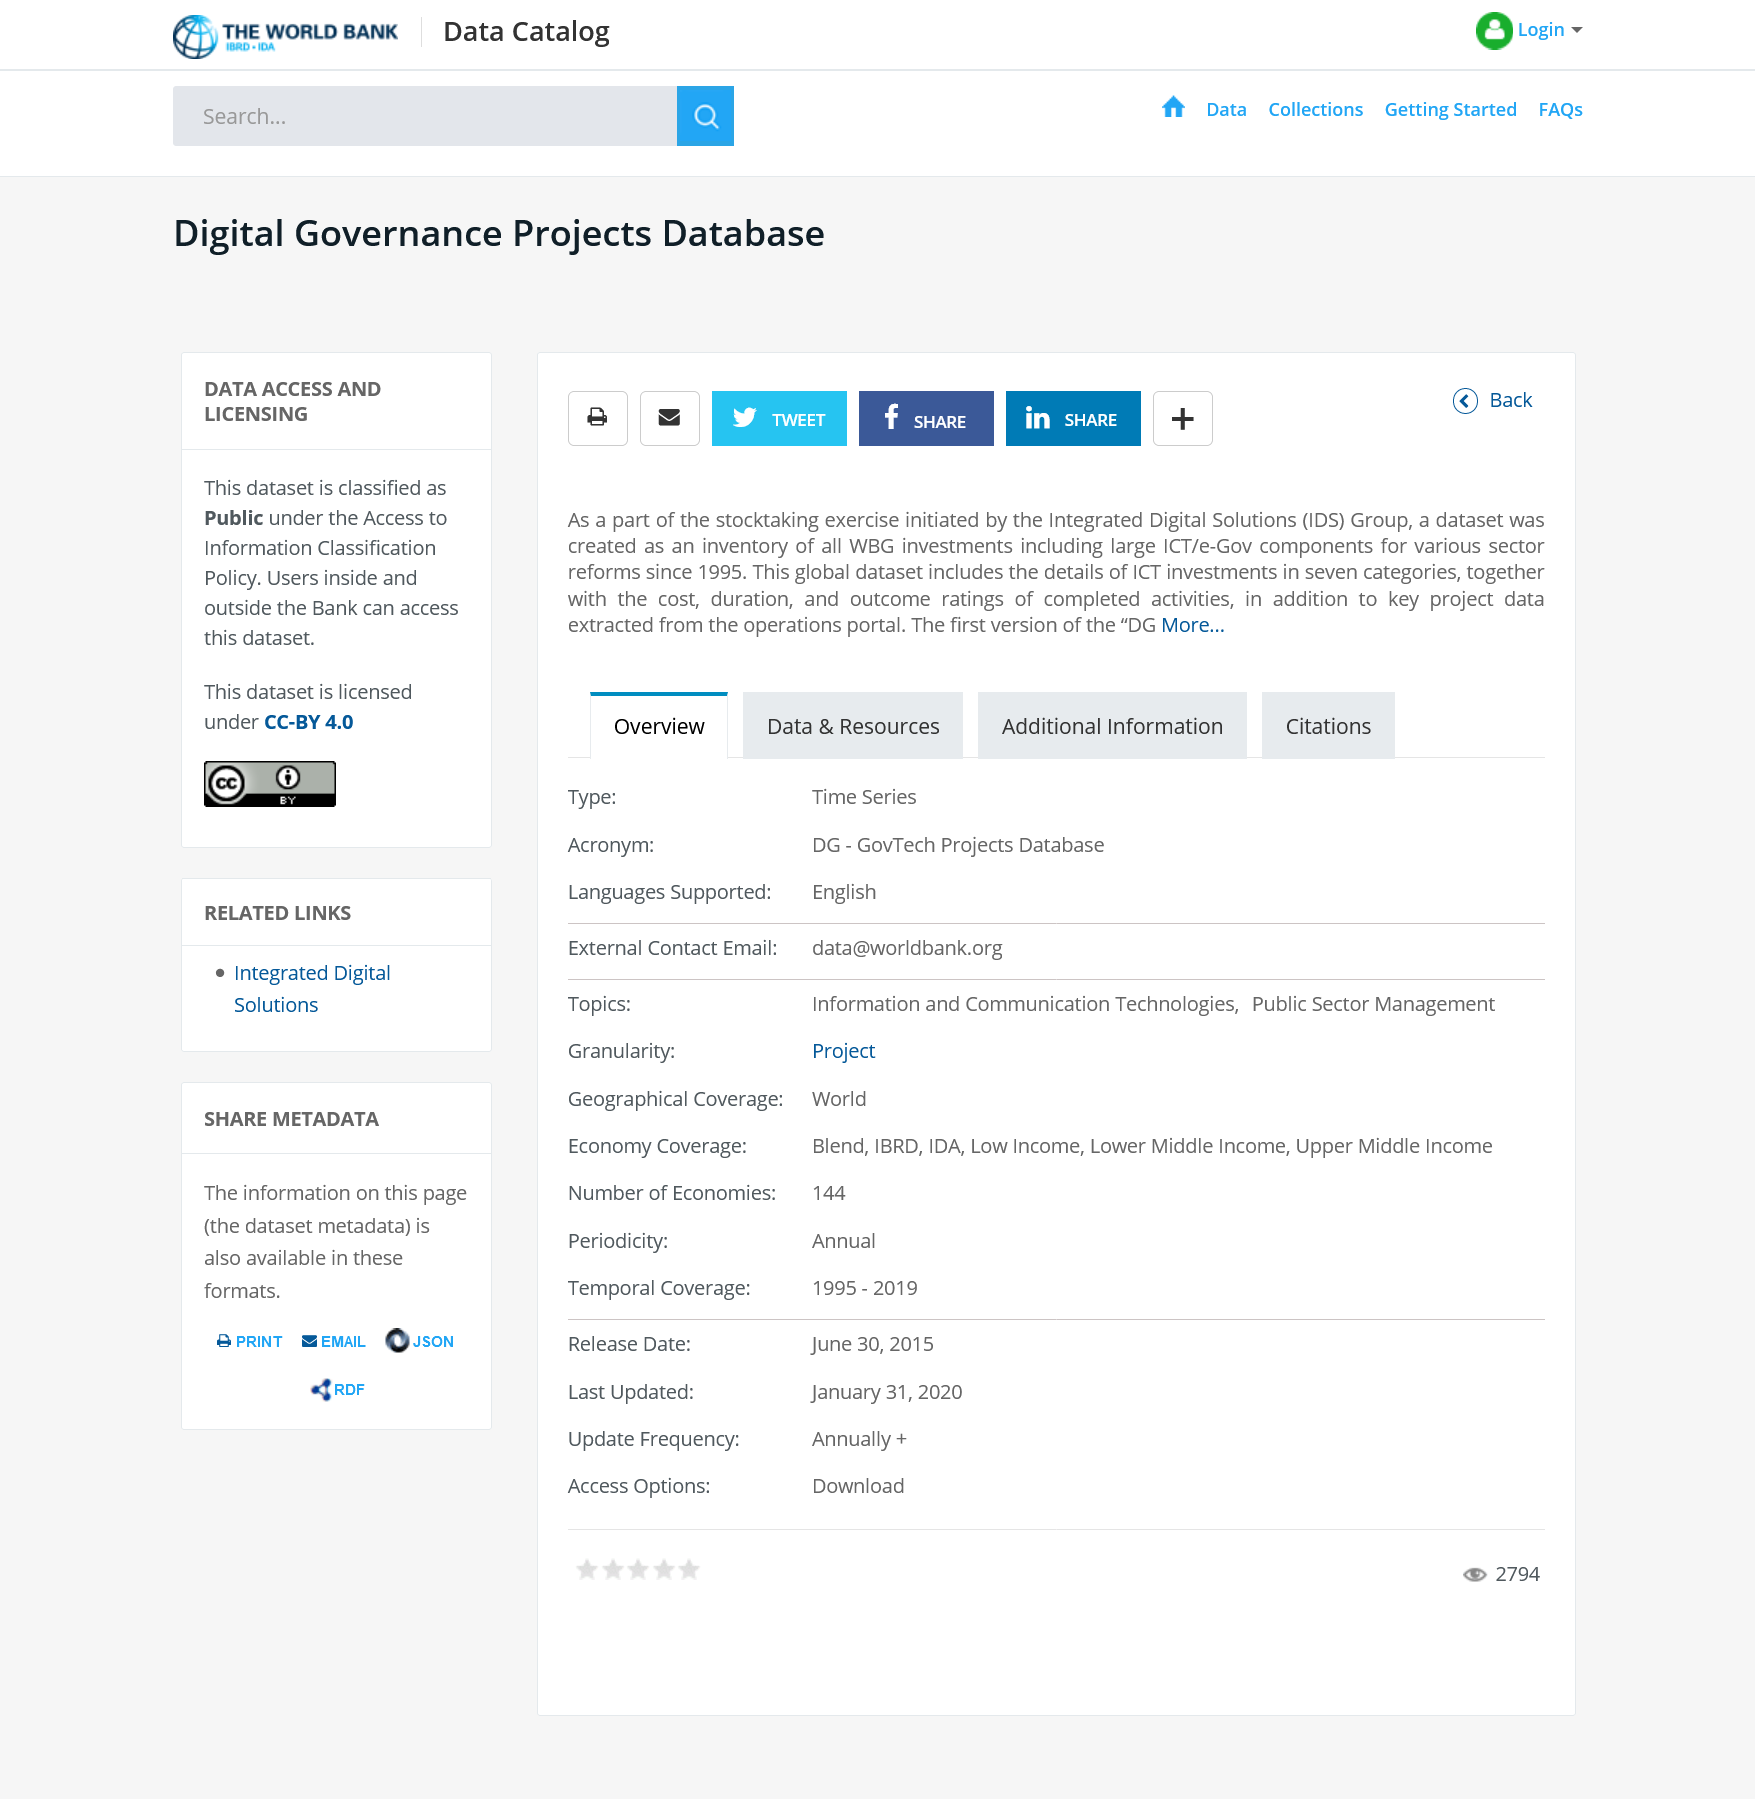Draw attention to some important aspects in this diagram. The data can be accessed by users outside the Bank. I request that you share this article on Twitter by saying 'Yes.' The stocktaking exercise was started in 1995. 